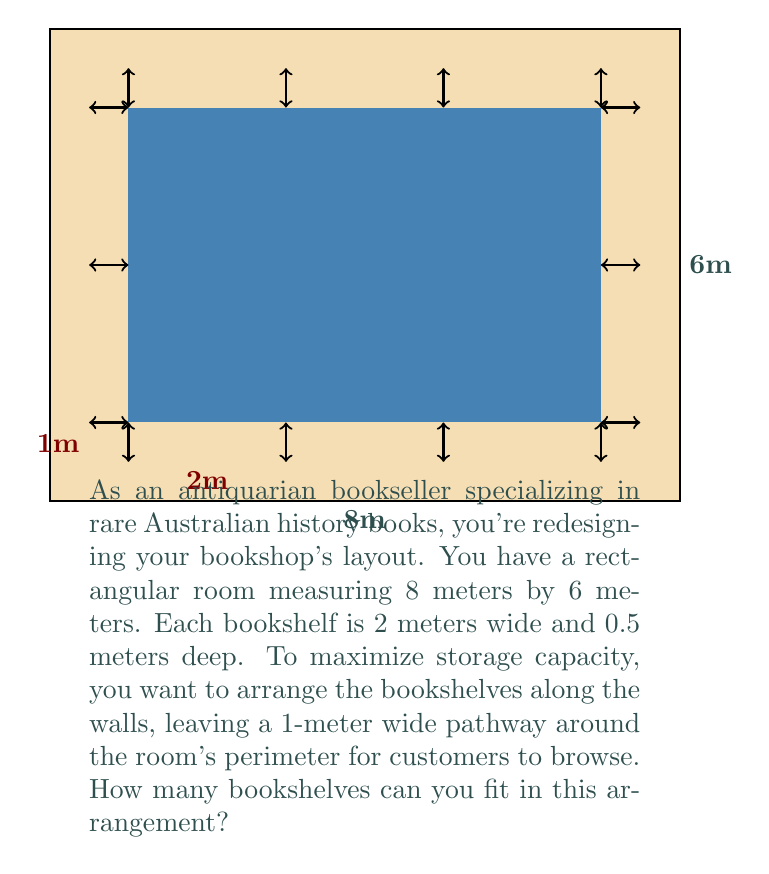Teach me how to tackle this problem. Let's approach this step-by-step:

1) First, we need to calculate the available wall space for bookshelves after accounting for the 1-meter pathway:
   - Length: $8m - (2 \times 1m) = 6m$
   - Width: $6m - (2 \times 1m) = 4m$

2) The total available wall length is:
   $$(2 \times 6m) + (2 \times 4m) = 12m + 8m = 20m$$

3) Each bookshelf is 2 meters wide. To find how many bookshelves we can fit, we divide the total available wall length by the width of each bookshelf:

   $$\frac{20m}{2m} = 10$$

Therefore, we can fit 10 bookshelves along the walls of the room.

4) Let's verify if this arrangement leaves enough space for the 0.5m depth of each bookshelf:
   - The pathway is 1m wide, which is greater than the 0.5m depth of the bookshelves.
   - This means the bookshelves can be placed without obstructing the pathway.

5) The arrangement would be:
   - 3 bookshelves on each of the 6m walls (6 total)
   - 2 bookshelves on each of the 4m walls (4 total)
   - 6 + 4 = 10 bookshelves in total
Answer: 10 bookshelves 